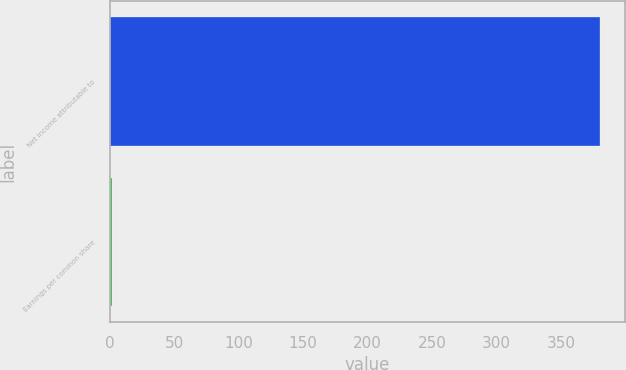Convert chart. <chart><loc_0><loc_0><loc_500><loc_500><bar_chart><fcel>Net income attributable to<fcel>Earnings per common share<nl><fcel>380<fcel>2.14<nl></chart> 